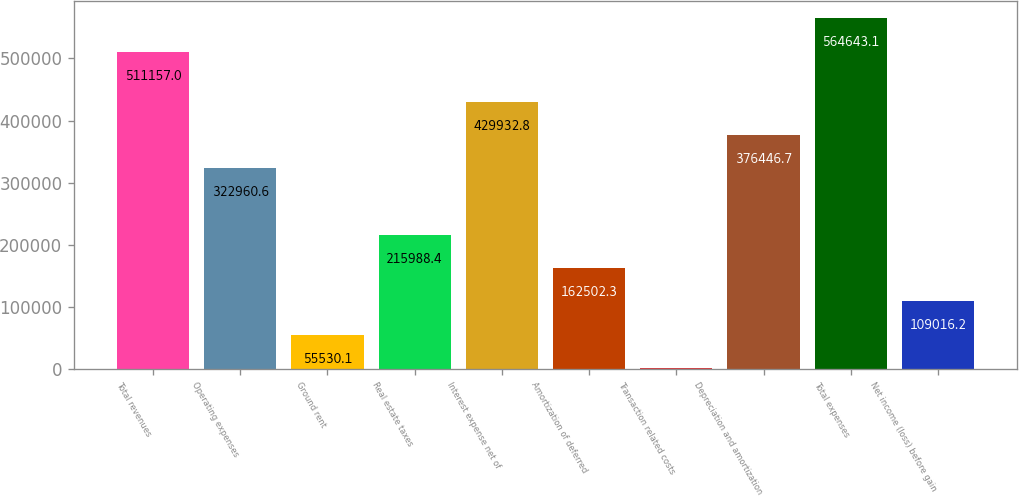Convert chart to OTSL. <chart><loc_0><loc_0><loc_500><loc_500><bar_chart><fcel>Total revenues<fcel>Operating expenses<fcel>Ground rent<fcel>Real estate taxes<fcel>Interest expense net of<fcel>Amortization of deferred<fcel>Transaction related costs<fcel>Depreciation and amortization<fcel>Total expenses<fcel>Net income (loss) before gain<nl><fcel>511157<fcel>322961<fcel>55530.1<fcel>215988<fcel>429933<fcel>162502<fcel>2044<fcel>376447<fcel>564643<fcel>109016<nl></chart> 